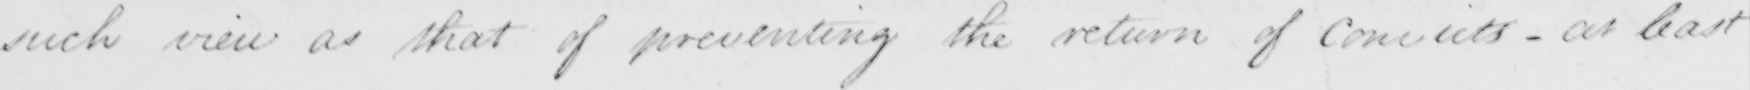Can you tell me what this handwritten text says? such view as that of preventing the return of Convicts - at least 